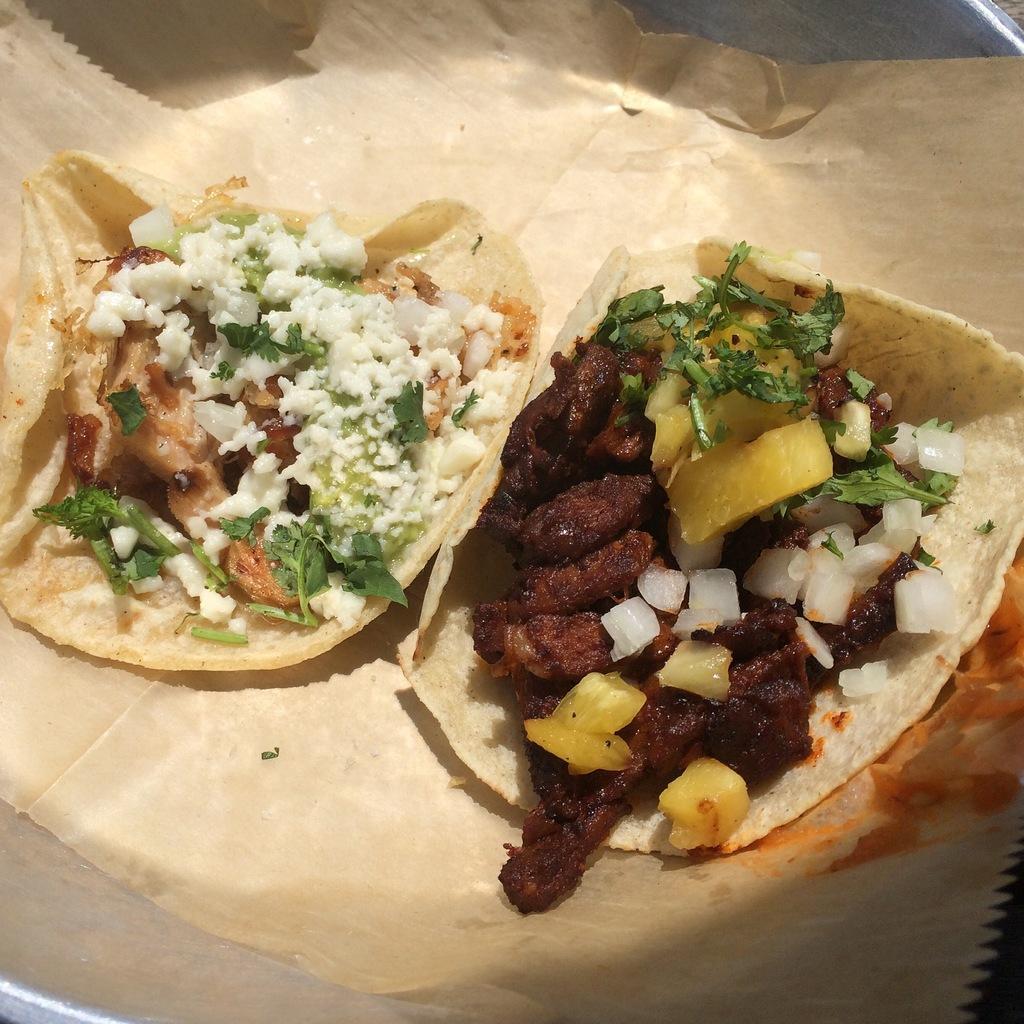How would you summarize this image in a sentence or two? In this image I can see the food on the brown color paper. I can see the food is colorful. The brown color paper is on the silver color plate. 